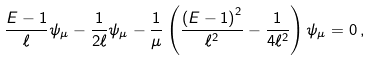Convert formula to latex. <formula><loc_0><loc_0><loc_500><loc_500>\frac { E - 1 } { \ell } \psi _ { \mu } - \frac { 1 } { 2 \ell } \psi _ { \mu } - \frac { 1 } { \mu } \left ( \frac { \left ( E - 1 \right ) ^ { 2 } } { \ell ^ { 2 } } - \frac { 1 } { 4 \ell ^ { 2 } } \right ) \psi _ { \mu } = 0 \, ,</formula> 